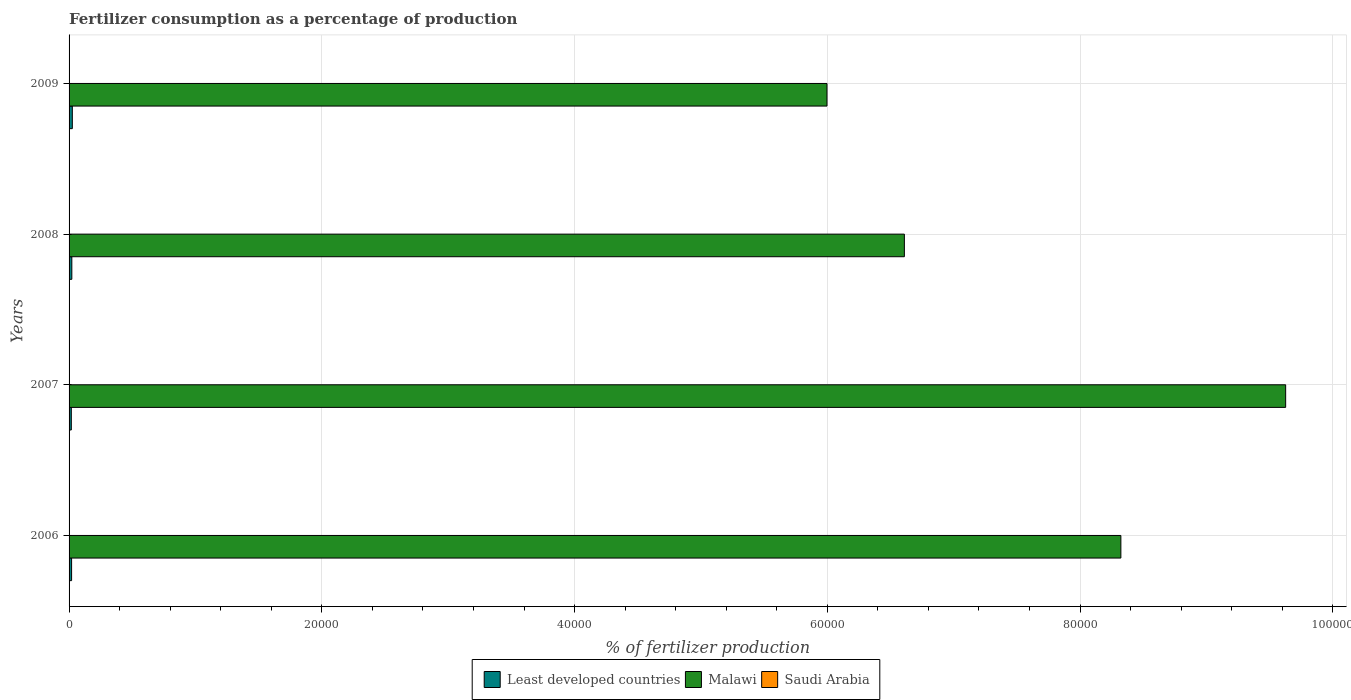How many different coloured bars are there?
Offer a terse response. 3. How many groups of bars are there?
Your response must be concise. 4. Are the number of bars on each tick of the Y-axis equal?
Your answer should be compact. Yes. How many bars are there on the 2nd tick from the top?
Provide a short and direct response. 3. What is the percentage of fertilizers consumed in Malawi in 2006?
Your answer should be compact. 8.32e+04. Across all years, what is the maximum percentage of fertilizers consumed in Saudi Arabia?
Provide a short and direct response. 21.6. Across all years, what is the minimum percentage of fertilizers consumed in Least developed countries?
Give a very brief answer. 177.87. In which year was the percentage of fertilizers consumed in Saudi Arabia minimum?
Your answer should be compact. 2009. What is the total percentage of fertilizers consumed in Saudi Arabia in the graph?
Provide a succinct answer. 65.73. What is the difference between the percentage of fertilizers consumed in Saudi Arabia in 2006 and that in 2008?
Provide a short and direct response. 7.11. What is the difference between the percentage of fertilizers consumed in Saudi Arabia in 2008 and the percentage of fertilizers consumed in Least developed countries in 2007?
Ensure brevity in your answer.  -163.38. What is the average percentage of fertilizers consumed in Malawi per year?
Provide a short and direct response. 7.64e+04. In the year 2007, what is the difference between the percentage of fertilizers consumed in Saudi Arabia and percentage of fertilizers consumed in Least developed countries?
Keep it short and to the point. -157.04. What is the ratio of the percentage of fertilizers consumed in Least developed countries in 2007 to that in 2008?
Ensure brevity in your answer.  0.82. Is the percentage of fertilizers consumed in Least developed countries in 2007 less than that in 2008?
Your response must be concise. Yes. Is the difference between the percentage of fertilizers consumed in Saudi Arabia in 2007 and 2008 greater than the difference between the percentage of fertilizers consumed in Least developed countries in 2007 and 2008?
Your answer should be very brief. Yes. What is the difference between the highest and the second highest percentage of fertilizers consumed in Least developed countries?
Give a very brief answer. 39.06. What is the difference between the highest and the lowest percentage of fertilizers consumed in Least developed countries?
Make the answer very short. 79.31. In how many years, is the percentage of fertilizers consumed in Malawi greater than the average percentage of fertilizers consumed in Malawi taken over all years?
Keep it short and to the point. 2. Is the sum of the percentage of fertilizers consumed in Saudi Arabia in 2007 and 2008 greater than the maximum percentage of fertilizers consumed in Least developed countries across all years?
Keep it short and to the point. No. What does the 2nd bar from the top in 2006 represents?
Ensure brevity in your answer.  Malawi. What does the 3rd bar from the bottom in 2006 represents?
Give a very brief answer. Saudi Arabia. Is it the case that in every year, the sum of the percentage of fertilizers consumed in Malawi and percentage of fertilizers consumed in Saudi Arabia is greater than the percentage of fertilizers consumed in Least developed countries?
Your response must be concise. Yes. How many bars are there?
Provide a short and direct response. 12. How many years are there in the graph?
Offer a very short reply. 4. What is the difference between two consecutive major ticks on the X-axis?
Provide a short and direct response. 2.00e+04. Are the values on the major ticks of X-axis written in scientific E-notation?
Provide a short and direct response. No. Does the graph contain any zero values?
Offer a terse response. No. Does the graph contain grids?
Your response must be concise. Yes. How are the legend labels stacked?
Keep it short and to the point. Horizontal. What is the title of the graph?
Your answer should be very brief. Fertilizer consumption as a percentage of production. Does "Saudi Arabia" appear as one of the legend labels in the graph?
Your answer should be very brief. Yes. What is the label or title of the X-axis?
Offer a very short reply. % of fertilizer production. What is the % of fertilizer production in Least developed countries in 2006?
Keep it short and to the point. 199.25. What is the % of fertilizer production in Malawi in 2006?
Offer a very short reply. 8.32e+04. What is the % of fertilizer production of Saudi Arabia in 2006?
Make the answer very short. 21.6. What is the % of fertilizer production in Least developed countries in 2007?
Your answer should be compact. 177.87. What is the % of fertilizer production of Malawi in 2007?
Provide a short and direct response. 9.63e+04. What is the % of fertilizer production of Saudi Arabia in 2007?
Offer a very short reply. 20.83. What is the % of fertilizer production in Least developed countries in 2008?
Your answer should be very brief. 218.12. What is the % of fertilizer production in Malawi in 2008?
Keep it short and to the point. 6.61e+04. What is the % of fertilizer production in Saudi Arabia in 2008?
Provide a short and direct response. 14.49. What is the % of fertilizer production in Least developed countries in 2009?
Give a very brief answer. 257.18. What is the % of fertilizer production in Malawi in 2009?
Give a very brief answer. 6.00e+04. What is the % of fertilizer production in Saudi Arabia in 2009?
Your response must be concise. 8.81. Across all years, what is the maximum % of fertilizer production in Least developed countries?
Give a very brief answer. 257.18. Across all years, what is the maximum % of fertilizer production of Malawi?
Keep it short and to the point. 9.63e+04. Across all years, what is the maximum % of fertilizer production of Saudi Arabia?
Your answer should be compact. 21.6. Across all years, what is the minimum % of fertilizer production in Least developed countries?
Your answer should be very brief. 177.87. Across all years, what is the minimum % of fertilizer production of Malawi?
Keep it short and to the point. 6.00e+04. Across all years, what is the minimum % of fertilizer production in Saudi Arabia?
Your response must be concise. 8.81. What is the total % of fertilizer production in Least developed countries in the graph?
Offer a terse response. 852.42. What is the total % of fertilizer production in Malawi in the graph?
Your answer should be very brief. 3.06e+05. What is the total % of fertilizer production of Saudi Arabia in the graph?
Keep it short and to the point. 65.73. What is the difference between the % of fertilizer production in Least developed countries in 2006 and that in 2007?
Give a very brief answer. 21.38. What is the difference between the % of fertilizer production in Malawi in 2006 and that in 2007?
Your response must be concise. -1.30e+04. What is the difference between the % of fertilizer production of Saudi Arabia in 2006 and that in 2007?
Your answer should be compact. 0.77. What is the difference between the % of fertilizer production of Least developed countries in 2006 and that in 2008?
Give a very brief answer. -18.87. What is the difference between the % of fertilizer production in Malawi in 2006 and that in 2008?
Give a very brief answer. 1.71e+04. What is the difference between the % of fertilizer production in Saudi Arabia in 2006 and that in 2008?
Your answer should be very brief. 7.11. What is the difference between the % of fertilizer production in Least developed countries in 2006 and that in 2009?
Give a very brief answer. -57.93. What is the difference between the % of fertilizer production of Malawi in 2006 and that in 2009?
Your answer should be compact. 2.33e+04. What is the difference between the % of fertilizer production in Saudi Arabia in 2006 and that in 2009?
Give a very brief answer. 12.8. What is the difference between the % of fertilizer production of Least developed countries in 2007 and that in 2008?
Offer a terse response. -40.25. What is the difference between the % of fertilizer production of Malawi in 2007 and that in 2008?
Ensure brevity in your answer.  3.02e+04. What is the difference between the % of fertilizer production of Saudi Arabia in 2007 and that in 2008?
Offer a very short reply. 6.34. What is the difference between the % of fertilizer production in Least developed countries in 2007 and that in 2009?
Provide a succinct answer. -79.31. What is the difference between the % of fertilizer production of Malawi in 2007 and that in 2009?
Provide a succinct answer. 3.63e+04. What is the difference between the % of fertilizer production of Saudi Arabia in 2007 and that in 2009?
Offer a terse response. 12.03. What is the difference between the % of fertilizer production in Least developed countries in 2008 and that in 2009?
Make the answer very short. -39.06. What is the difference between the % of fertilizer production in Malawi in 2008 and that in 2009?
Give a very brief answer. 6122.77. What is the difference between the % of fertilizer production of Saudi Arabia in 2008 and that in 2009?
Keep it short and to the point. 5.69. What is the difference between the % of fertilizer production of Least developed countries in 2006 and the % of fertilizer production of Malawi in 2007?
Provide a succinct answer. -9.61e+04. What is the difference between the % of fertilizer production of Least developed countries in 2006 and the % of fertilizer production of Saudi Arabia in 2007?
Provide a short and direct response. 178.42. What is the difference between the % of fertilizer production of Malawi in 2006 and the % of fertilizer production of Saudi Arabia in 2007?
Give a very brief answer. 8.32e+04. What is the difference between the % of fertilizer production of Least developed countries in 2006 and the % of fertilizer production of Malawi in 2008?
Ensure brevity in your answer.  -6.59e+04. What is the difference between the % of fertilizer production in Least developed countries in 2006 and the % of fertilizer production in Saudi Arabia in 2008?
Your answer should be very brief. 184.76. What is the difference between the % of fertilizer production in Malawi in 2006 and the % of fertilizer production in Saudi Arabia in 2008?
Give a very brief answer. 8.32e+04. What is the difference between the % of fertilizer production of Least developed countries in 2006 and the % of fertilizer production of Malawi in 2009?
Keep it short and to the point. -5.98e+04. What is the difference between the % of fertilizer production of Least developed countries in 2006 and the % of fertilizer production of Saudi Arabia in 2009?
Keep it short and to the point. 190.44. What is the difference between the % of fertilizer production in Malawi in 2006 and the % of fertilizer production in Saudi Arabia in 2009?
Offer a very short reply. 8.32e+04. What is the difference between the % of fertilizer production of Least developed countries in 2007 and the % of fertilizer production of Malawi in 2008?
Your answer should be compact. -6.59e+04. What is the difference between the % of fertilizer production in Least developed countries in 2007 and the % of fertilizer production in Saudi Arabia in 2008?
Your answer should be very brief. 163.38. What is the difference between the % of fertilizer production in Malawi in 2007 and the % of fertilizer production in Saudi Arabia in 2008?
Keep it short and to the point. 9.63e+04. What is the difference between the % of fertilizer production of Least developed countries in 2007 and the % of fertilizer production of Malawi in 2009?
Make the answer very short. -5.98e+04. What is the difference between the % of fertilizer production in Least developed countries in 2007 and the % of fertilizer production in Saudi Arabia in 2009?
Make the answer very short. 169.07. What is the difference between the % of fertilizer production of Malawi in 2007 and the % of fertilizer production of Saudi Arabia in 2009?
Provide a succinct answer. 9.63e+04. What is the difference between the % of fertilizer production of Least developed countries in 2008 and the % of fertilizer production of Malawi in 2009?
Give a very brief answer. -5.98e+04. What is the difference between the % of fertilizer production of Least developed countries in 2008 and the % of fertilizer production of Saudi Arabia in 2009?
Offer a terse response. 209.31. What is the difference between the % of fertilizer production of Malawi in 2008 and the % of fertilizer production of Saudi Arabia in 2009?
Make the answer very short. 6.61e+04. What is the average % of fertilizer production of Least developed countries per year?
Offer a very short reply. 213.11. What is the average % of fertilizer production of Malawi per year?
Ensure brevity in your answer.  7.64e+04. What is the average % of fertilizer production in Saudi Arabia per year?
Offer a very short reply. 16.43. In the year 2006, what is the difference between the % of fertilizer production in Least developed countries and % of fertilizer production in Malawi?
Give a very brief answer. -8.30e+04. In the year 2006, what is the difference between the % of fertilizer production in Least developed countries and % of fertilizer production in Saudi Arabia?
Offer a very short reply. 177.65. In the year 2006, what is the difference between the % of fertilizer production of Malawi and % of fertilizer production of Saudi Arabia?
Give a very brief answer. 8.32e+04. In the year 2007, what is the difference between the % of fertilizer production in Least developed countries and % of fertilizer production in Malawi?
Give a very brief answer. -9.61e+04. In the year 2007, what is the difference between the % of fertilizer production in Least developed countries and % of fertilizer production in Saudi Arabia?
Your answer should be compact. 157.04. In the year 2007, what is the difference between the % of fertilizer production of Malawi and % of fertilizer production of Saudi Arabia?
Give a very brief answer. 9.63e+04. In the year 2008, what is the difference between the % of fertilizer production in Least developed countries and % of fertilizer production in Malawi?
Make the answer very short. -6.59e+04. In the year 2008, what is the difference between the % of fertilizer production in Least developed countries and % of fertilizer production in Saudi Arabia?
Offer a terse response. 203.63. In the year 2008, what is the difference between the % of fertilizer production of Malawi and % of fertilizer production of Saudi Arabia?
Offer a very short reply. 6.61e+04. In the year 2009, what is the difference between the % of fertilizer production in Least developed countries and % of fertilizer production in Malawi?
Keep it short and to the point. -5.97e+04. In the year 2009, what is the difference between the % of fertilizer production of Least developed countries and % of fertilizer production of Saudi Arabia?
Provide a short and direct response. 248.38. In the year 2009, what is the difference between the % of fertilizer production of Malawi and % of fertilizer production of Saudi Arabia?
Your response must be concise. 6.00e+04. What is the ratio of the % of fertilizer production in Least developed countries in 2006 to that in 2007?
Your answer should be compact. 1.12. What is the ratio of the % of fertilizer production of Malawi in 2006 to that in 2007?
Provide a short and direct response. 0.86. What is the ratio of the % of fertilizer production in Saudi Arabia in 2006 to that in 2007?
Your answer should be very brief. 1.04. What is the ratio of the % of fertilizer production in Least developed countries in 2006 to that in 2008?
Your answer should be very brief. 0.91. What is the ratio of the % of fertilizer production in Malawi in 2006 to that in 2008?
Your response must be concise. 1.26. What is the ratio of the % of fertilizer production in Saudi Arabia in 2006 to that in 2008?
Offer a terse response. 1.49. What is the ratio of the % of fertilizer production in Least developed countries in 2006 to that in 2009?
Provide a short and direct response. 0.77. What is the ratio of the % of fertilizer production in Malawi in 2006 to that in 2009?
Give a very brief answer. 1.39. What is the ratio of the % of fertilizer production in Saudi Arabia in 2006 to that in 2009?
Ensure brevity in your answer.  2.45. What is the ratio of the % of fertilizer production of Least developed countries in 2007 to that in 2008?
Provide a succinct answer. 0.82. What is the ratio of the % of fertilizer production of Malawi in 2007 to that in 2008?
Keep it short and to the point. 1.46. What is the ratio of the % of fertilizer production of Saudi Arabia in 2007 to that in 2008?
Your answer should be very brief. 1.44. What is the ratio of the % of fertilizer production of Least developed countries in 2007 to that in 2009?
Your response must be concise. 0.69. What is the ratio of the % of fertilizer production in Malawi in 2007 to that in 2009?
Give a very brief answer. 1.61. What is the ratio of the % of fertilizer production in Saudi Arabia in 2007 to that in 2009?
Offer a very short reply. 2.37. What is the ratio of the % of fertilizer production in Least developed countries in 2008 to that in 2009?
Your answer should be compact. 0.85. What is the ratio of the % of fertilizer production in Malawi in 2008 to that in 2009?
Your response must be concise. 1.1. What is the ratio of the % of fertilizer production of Saudi Arabia in 2008 to that in 2009?
Make the answer very short. 1.65. What is the difference between the highest and the second highest % of fertilizer production of Least developed countries?
Provide a short and direct response. 39.06. What is the difference between the highest and the second highest % of fertilizer production in Malawi?
Your response must be concise. 1.30e+04. What is the difference between the highest and the second highest % of fertilizer production in Saudi Arabia?
Ensure brevity in your answer.  0.77. What is the difference between the highest and the lowest % of fertilizer production in Least developed countries?
Provide a succinct answer. 79.31. What is the difference between the highest and the lowest % of fertilizer production in Malawi?
Offer a very short reply. 3.63e+04. What is the difference between the highest and the lowest % of fertilizer production in Saudi Arabia?
Ensure brevity in your answer.  12.8. 